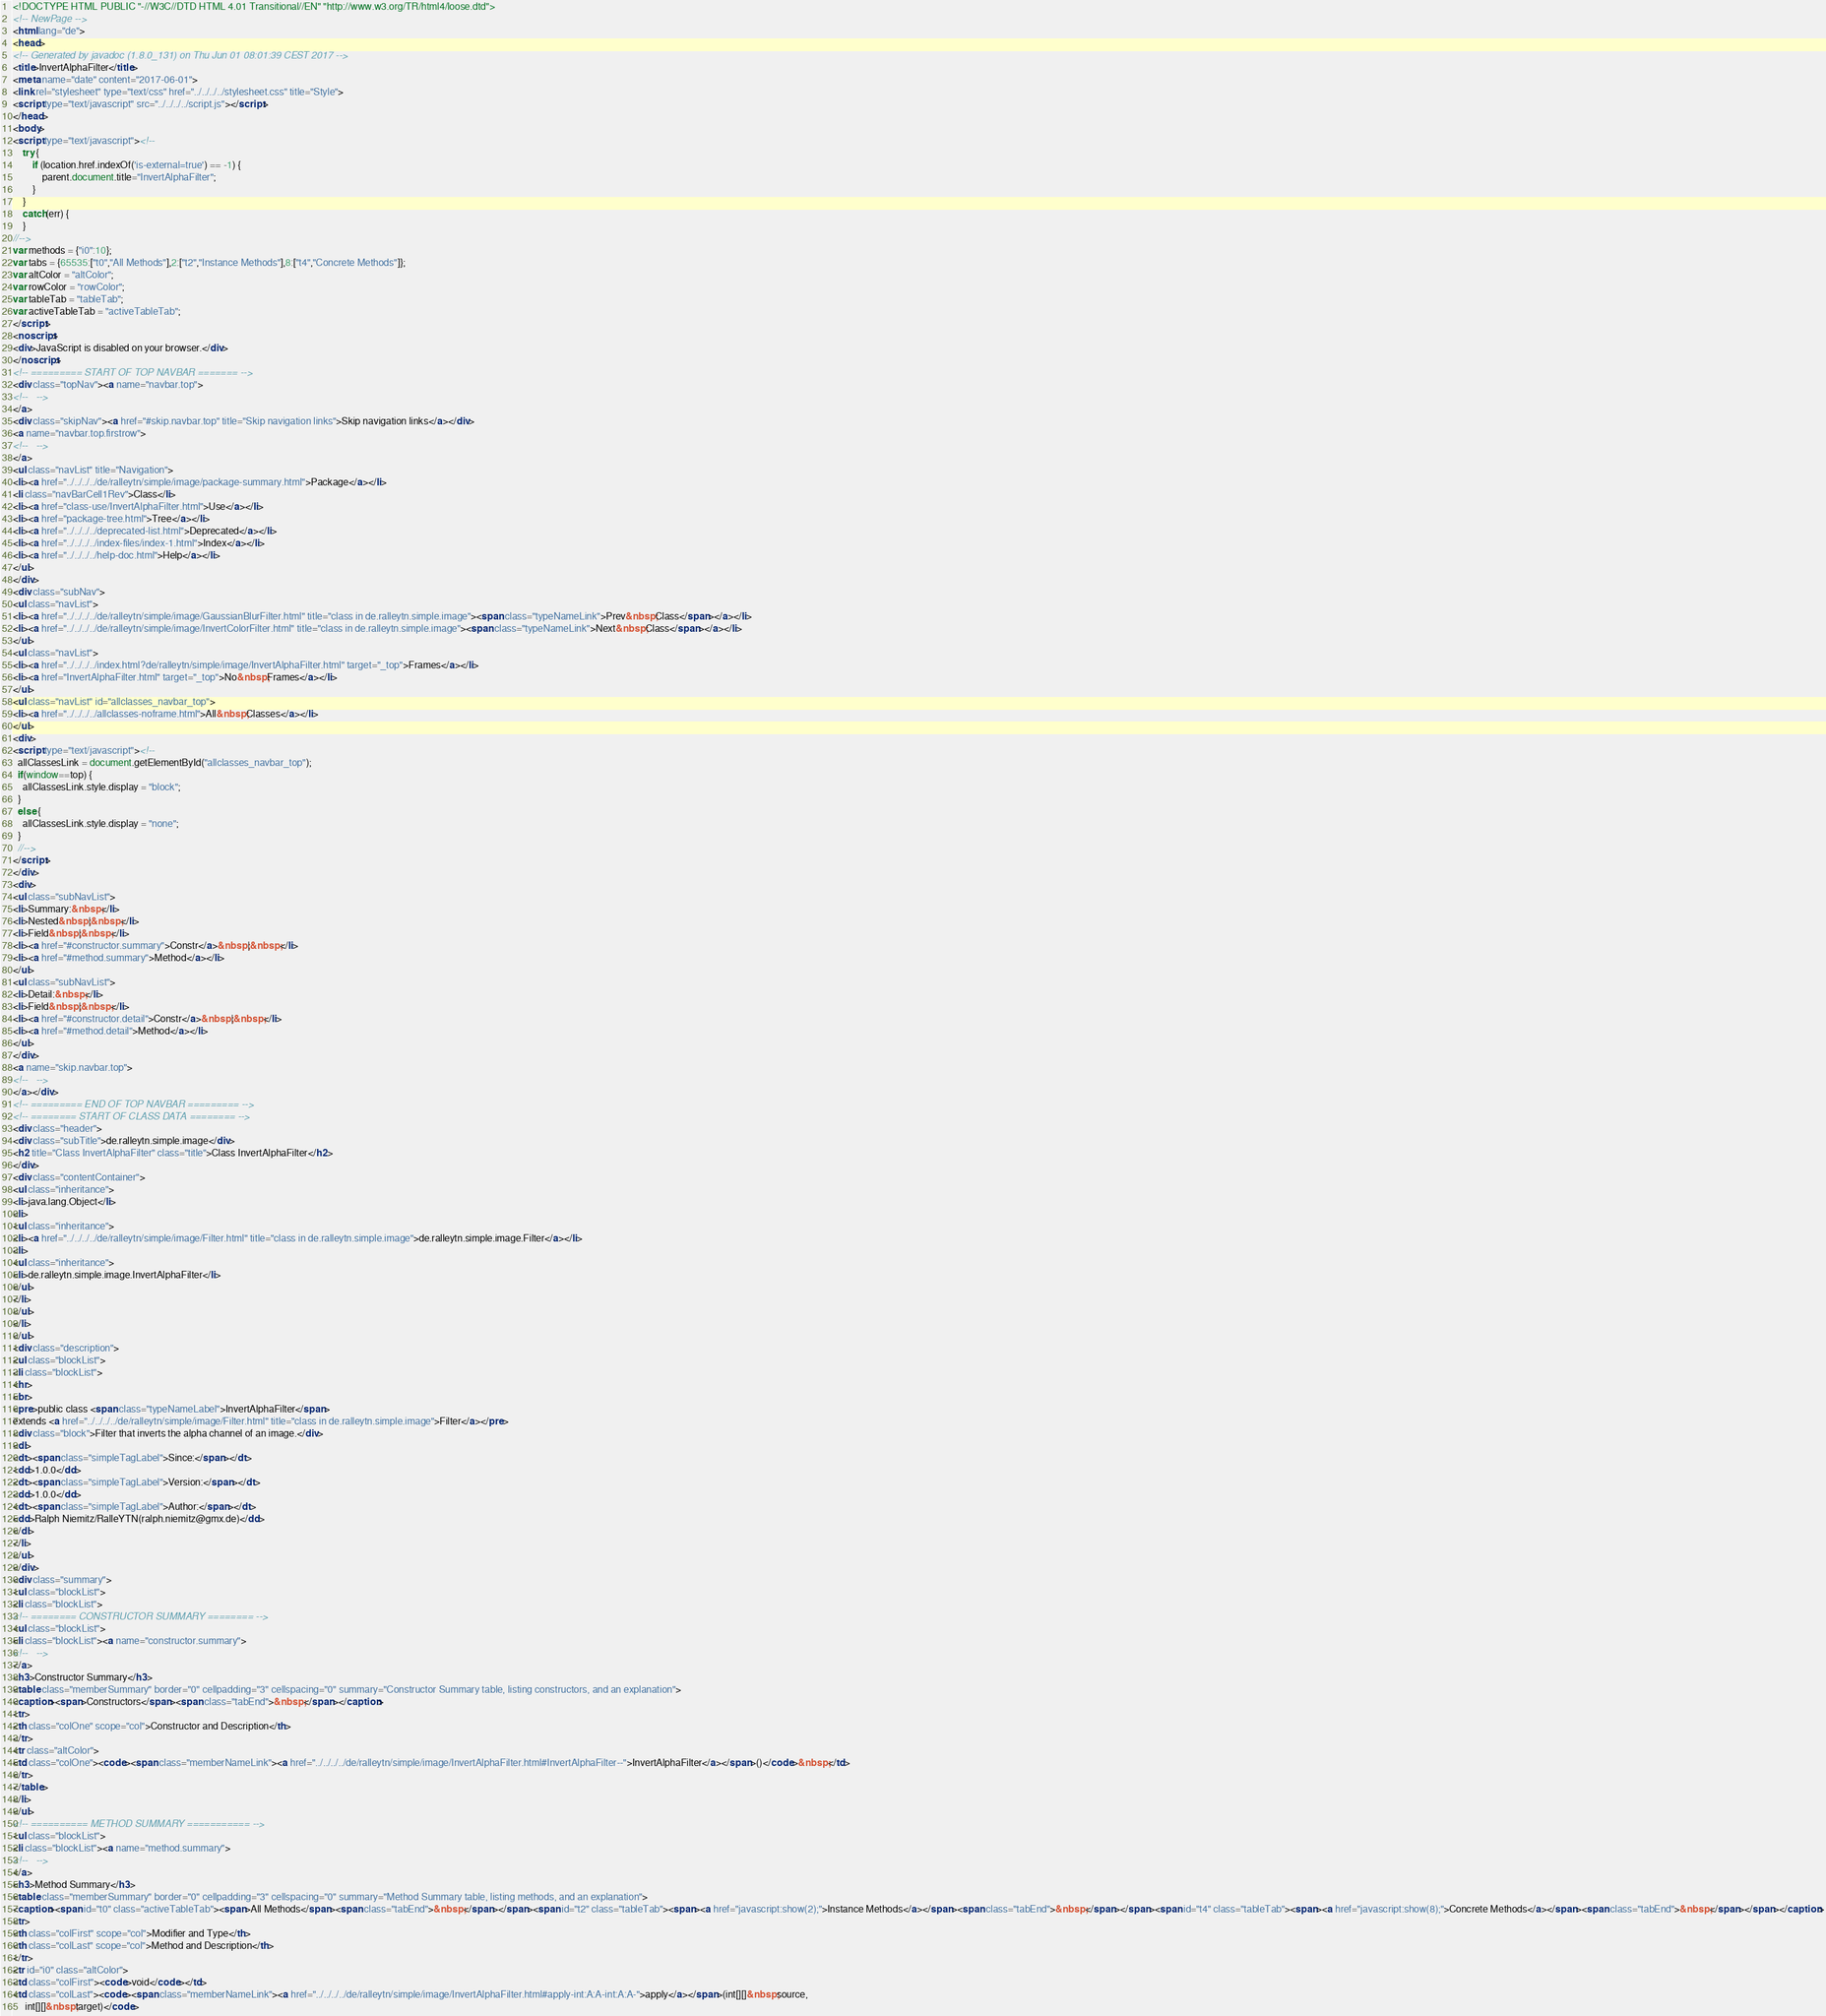<code> <loc_0><loc_0><loc_500><loc_500><_HTML_><!DOCTYPE HTML PUBLIC "-//W3C//DTD HTML 4.01 Transitional//EN" "http://www.w3.org/TR/html4/loose.dtd">
<!-- NewPage -->
<html lang="de">
<head>
<!-- Generated by javadoc (1.8.0_131) on Thu Jun 01 08:01:39 CEST 2017 -->
<title>InvertAlphaFilter</title>
<meta name="date" content="2017-06-01">
<link rel="stylesheet" type="text/css" href="../../../../stylesheet.css" title="Style">
<script type="text/javascript" src="../../../../script.js"></script>
</head>
<body>
<script type="text/javascript"><!--
    try {
        if (location.href.indexOf('is-external=true') == -1) {
            parent.document.title="InvertAlphaFilter";
        }
    }
    catch(err) {
    }
//-->
var methods = {"i0":10};
var tabs = {65535:["t0","All Methods"],2:["t2","Instance Methods"],8:["t4","Concrete Methods"]};
var altColor = "altColor";
var rowColor = "rowColor";
var tableTab = "tableTab";
var activeTableTab = "activeTableTab";
</script>
<noscript>
<div>JavaScript is disabled on your browser.</div>
</noscript>
<!-- ========= START OF TOP NAVBAR ======= -->
<div class="topNav"><a name="navbar.top">
<!--   -->
</a>
<div class="skipNav"><a href="#skip.navbar.top" title="Skip navigation links">Skip navigation links</a></div>
<a name="navbar.top.firstrow">
<!--   -->
</a>
<ul class="navList" title="Navigation">
<li><a href="../../../../de/ralleytn/simple/image/package-summary.html">Package</a></li>
<li class="navBarCell1Rev">Class</li>
<li><a href="class-use/InvertAlphaFilter.html">Use</a></li>
<li><a href="package-tree.html">Tree</a></li>
<li><a href="../../../../deprecated-list.html">Deprecated</a></li>
<li><a href="../../../../index-files/index-1.html">Index</a></li>
<li><a href="../../../../help-doc.html">Help</a></li>
</ul>
</div>
<div class="subNav">
<ul class="navList">
<li><a href="../../../../de/ralleytn/simple/image/GaussianBlurFilter.html" title="class in de.ralleytn.simple.image"><span class="typeNameLink">Prev&nbsp;Class</span></a></li>
<li><a href="../../../../de/ralleytn/simple/image/InvertColorFilter.html" title="class in de.ralleytn.simple.image"><span class="typeNameLink">Next&nbsp;Class</span></a></li>
</ul>
<ul class="navList">
<li><a href="../../../../index.html?de/ralleytn/simple/image/InvertAlphaFilter.html" target="_top">Frames</a></li>
<li><a href="InvertAlphaFilter.html" target="_top">No&nbsp;Frames</a></li>
</ul>
<ul class="navList" id="allclasses_navbar_top">
<li><a href="../../../../allclasses-noframe.html">All&nbsp;Classes</a></li>
</ul>
<div>
<script type="text/javascript"><!--
  allClassesLink = document.getElementById("allclasses_navbar_top");
  if(window==top) {
    allClassesLink.style.display = "block";
  }
  else {
    allClassesLink.style.display = "none";
  }
  //-->
</script>
</div>
<div>
<ul class="subNavList">
<li>Summary:&nbsp;</li>
<li>Nested&nbsp;|&nbsp;</li>
<li>Field&nbsp;|&nbsp;</li>
<li><a href="#constructor.summary">Constr</a>&nbsp;|&nbsp;</li>
<li><a href="#method.summary">Method</a></li>
</ul>
<ul class="subNavList">
<li>Detail:&nbsp;</li>
<li>Field&nbsp;|&nbsp;</li>
<li><a href="#constructor.detail">Constr</a>&nbsp;|&nbsp;</li>
<li><a href="#method.detail">Method</a></li>
</ul>
</div>
<a name="skip.navbar.top">
<!--   -->
</a></div>
<!-- ========= END OF TOP NAVBAR ========= -->
<!-- ======== START OF CLASS DATA ======== -->
<div class="header">
<div class="subTitle">de.ralleytn.simple.image</div>
<h2 title="Class InvertAlphaFilter" class="title">Class InvertAlphaFilter</h2>
</div>
<div class="contentContainer">
<ul class="inheritance">
<li>java.lang.Object</li>
<li>
<ul class="inheritance">
<li><a href="../../../../de/ralleytn/simple/image/Filter.html" title="class in de.ralleytn.simple.image">de.ralleytn.simple.image.Filter</a></li>
<li>
<ul class="inheritance">
<li>de.ralleytn.simple.image.InvertAlphaFilter</li>
</ul>
</li>
</ul>
</li>
</ul>
<div class="description">
<ul class="blockList">
<li class="blockList">
<hr>
<br>
<pre>public class <span class="typeNameLabel">InvertAlphaFilter</span>
extends <a href="../../../../de/ralleytn/simple/image/Filter.html" title="class in de.ralleytn.simple.image">Filter</a></pre>
<div class="block">Filter that inverts the alpha channel of an image.</div>
<dl>
<dt><span class="simpleTagLabel">Since:</span></dt>
<dd>1.0.0</dd>
<dt><span class="simpleTagLabel">Version:</span></dt>
<dd>1.0.0</dd>
<dt><span class="simpleTagLabel">Author:</span></dt>
<dd>Ralph Niemitz/RalleYTN(ralph.niemitz@gmx.de)</dd>
</dl>
</li>
</ul>
</div>
<div class="summary">
<ul class="blockList">
<li class="blockList">
<!-- ======== CONSTRUCTOR SUMMARY ======== -->
<ul class="blockList">
<li class="blockList"><a name="constructor.summary">
<!--   -->
</a>
<h3>Constructor Summary</h3>
<table class="memberSummary" border="0" cellpadding="3" cellspacing="0" summary="Constructor Summary table, listing constructors, and an explanation">
<caption><span>Constructors</span><span class="tabEnd">&nbsp;</span></caption>
<tr>
<th class="colOne" scope="col">Constructor and Description</th>
</tr>
<tr class="altColor">
<td class="colOne"><code><span class="memberNameLink"><a href="../../../../de/ralleytn/simple/image/InvertAlphaFilter.html#InvertAlphaFilter--">InvertAlphaFilter</a></span>()</code>&nbsp;</td>
</tr>
</table>
</li>
</ul>
<!-- ========== METHOD SUMMARY =========== -->
<ul class="blockList">
<li class="blockList"><a name="method.summary">
<!--   -->
</a>
<h3>Method Summary</h3>
<table class="memberSummary" border="0" cellpadding="3" cellspacing="0" summary="Method Summary table, listing methods, and an explanation">
<caption><span id="t0" class="activeTableTab"><span>All Methods</span><span class="tabEnd">&nbsp;</span></span><span id="t2" class="tableTab"><span><a href="javascript:show(2);">Instance Methods</a></span><span class="tabEnd">&nbsp;</span></span><span id="t4" class="tableTab"><span><a href="javascript:show(8);">Concrete Methods</a></span><span class="tabEnd">&nbsp;</span></span></caption>
<tr>
<th class="colFirst" scope="col">Modifier and Type</th>
<th class="colLast" scope="col">Method and Description</th>
</tr>
<tr id="i0" class="altColor">
<td class="colFirst"><code>void</code></td>
<td class="colLast"><code><span class="memberNameLink"><a href="../../../../de/ralleytn/simple/image/InvertAlphaFilter.html#apply-int:A:A-int:A:A-">apply</a></span>(int[][]&nbsp;source,
     int[][]&nbsp;target)</code></code> 